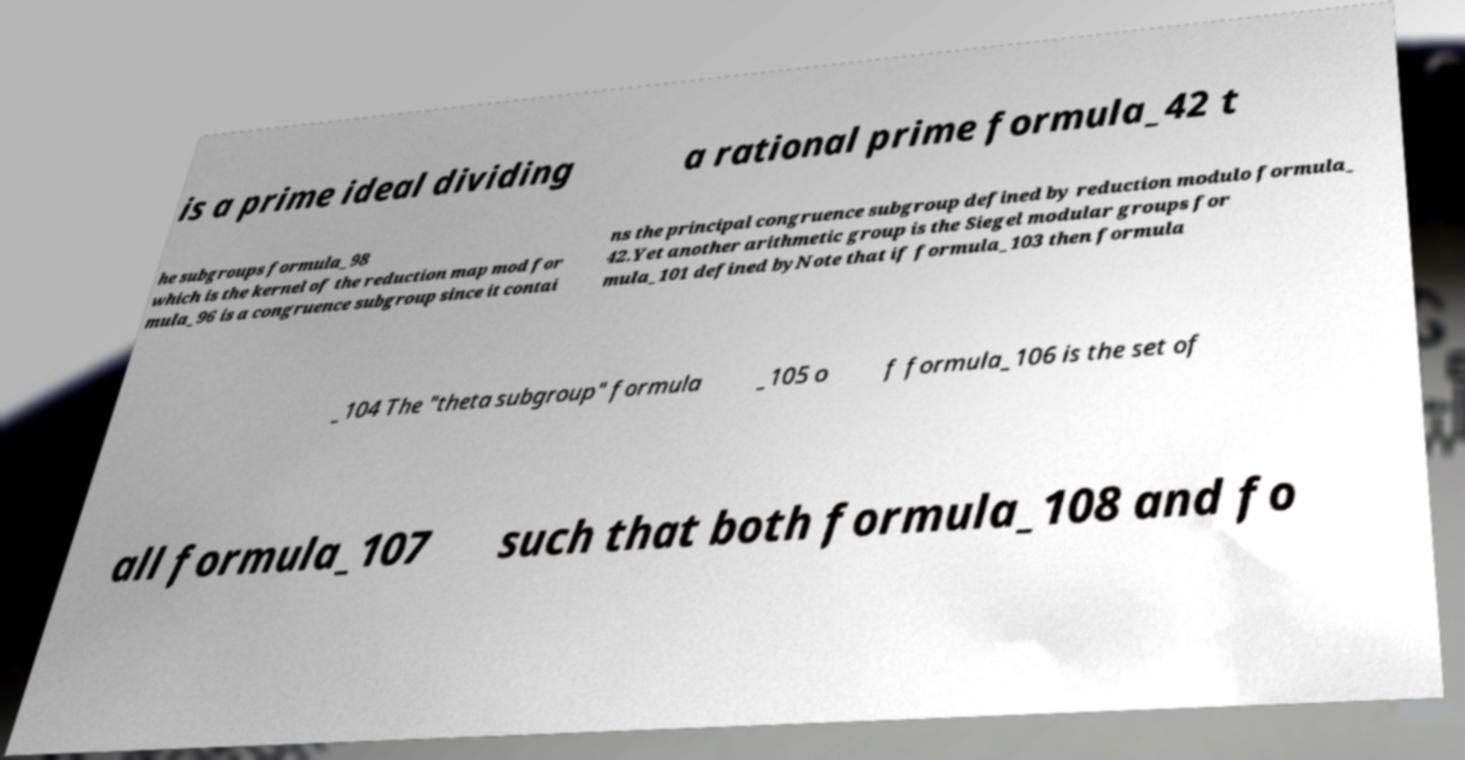Could you assist in decoding the text presented in this image and type it out clearly? is a prime ideal dividing a rational prime formula_42 t he subgroups formula_98 which is the kernel of the reduction map mod for mula_96 is a congruence subgroup since it contai ns the principal congruence subgroup defined by reduction modulo formula_ 42.Yet another arithmetic group is the Siegel modular groups for mula_101 defined byNote that if formula_103 then formula _104 The "theta subgroup" formula _105 o f formula_106 is the set of all formula_107 such that both formula_108 and fo 